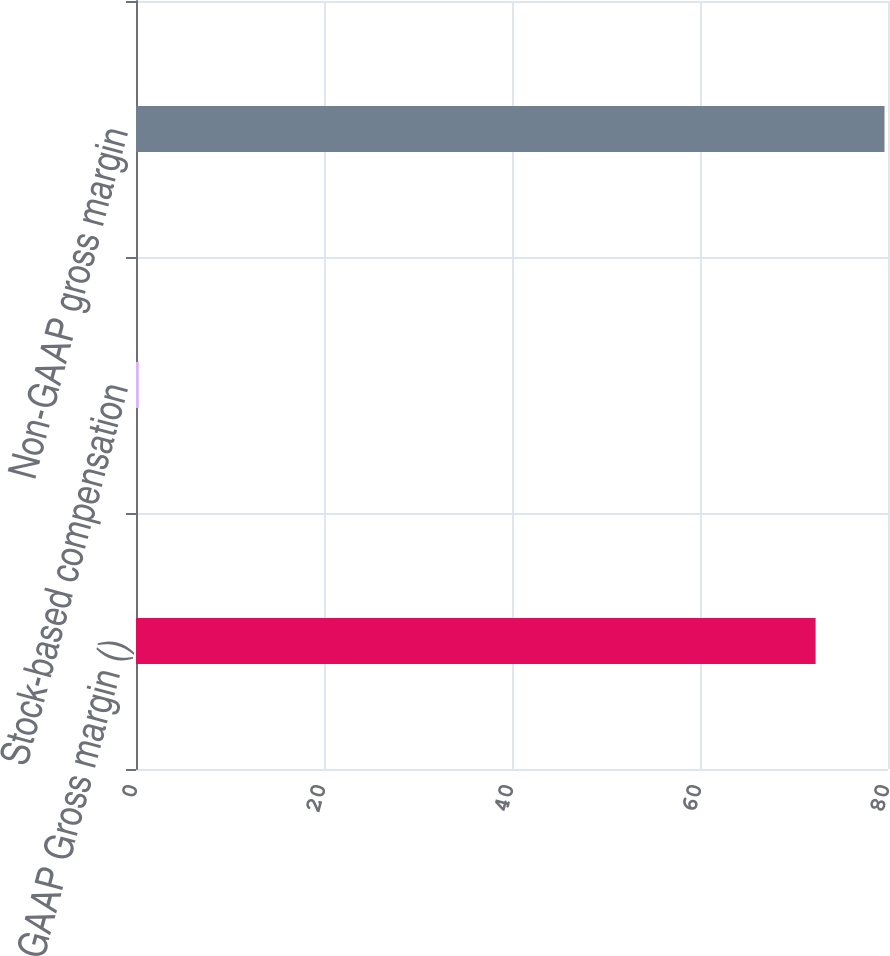Convert chart. <chart><loc_0><loc_0><loc_500><loc_500><bar_chart><fcel>GAAP Gross margin ()<fcel>Stock-based compensation<fcel>Non-GAAP gross margin<nl><fcel>72.3<fcel>0.3<fcel>79.63<nl></chart> 